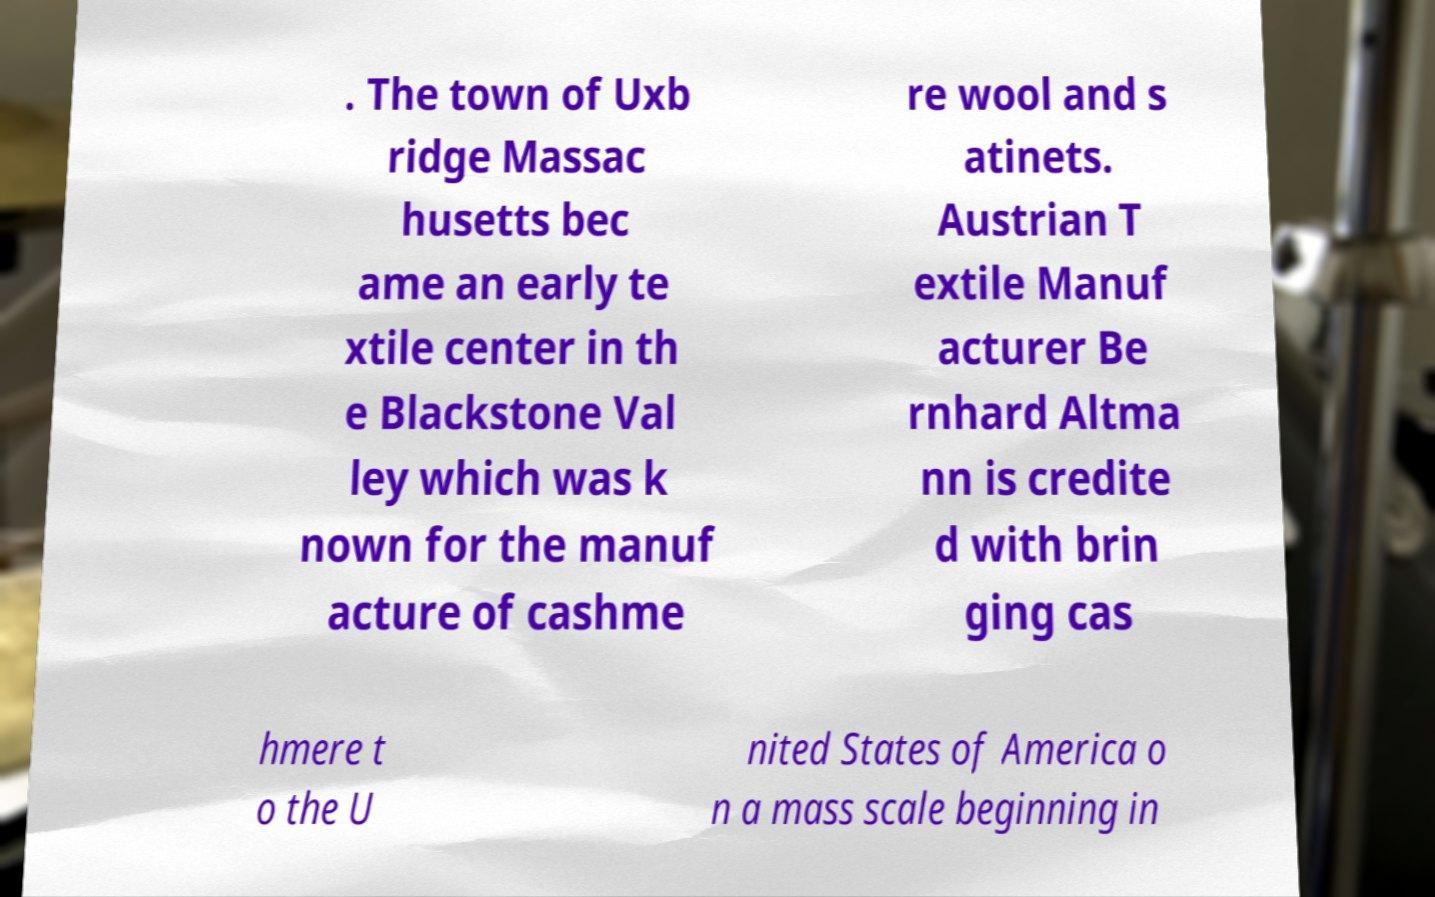Can you read and provide the text displayed in the image?This photo seems to have some interesting text. Can you extract and type it out for me? . The town of Uxb ridge Massac husetts bec ame an early te xtile center in th e Blackstone Val ley which was k nown for the manuf acture of cashme re wool and s atinets. Austrian T extile Manuf acturer Be rnhard Altma nn is credite d with brin ging cas hmere t o the U nited States of America o n a mass scale beginning in 